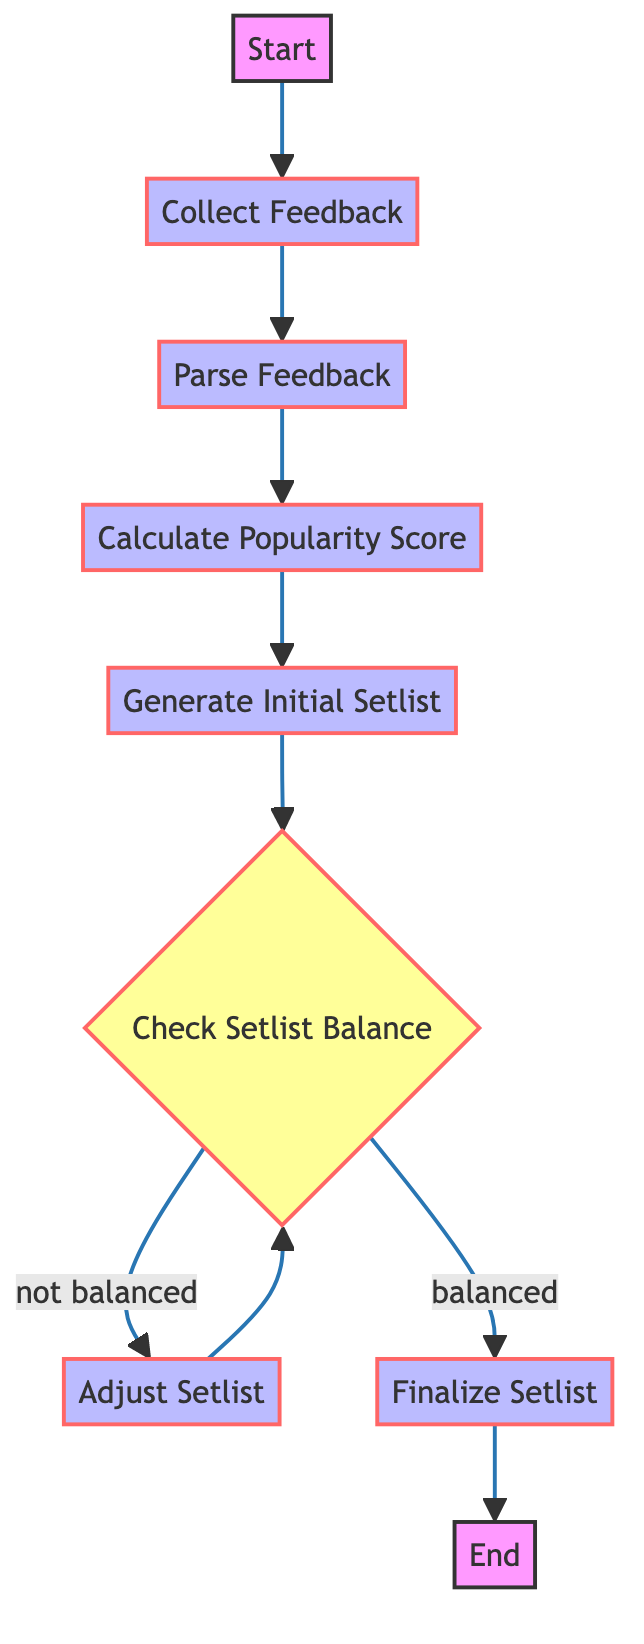What is the first step in the setlist generation process? The first step, as indicated in the diagram, is "Collect Feedback." This is the initial action that sets off the entire process of creating a setlist based on audience input.
Answer: Collect Feedback How many process nodes are present in the flowchart? By counting the nodes marked as "process" in the diagram, we identify a total of five process nodes. They include "Collect Feedback," "Parse Feedback," "Calculate Popularity Score," "Generate Initial Setlist," and "Adjust Setlist."
Answer: Five What action is taken if the setlist is balanced? The action taken when the setlist is balanced, as shown in the flowchart, is to "Finalize Setlist." This indicates that the setlist meets the criteria and is ready for rehearsal.
Answer: Finalize Setlist What happens if the setlist is not balanced? If the setlist is not balanced, the flowchart directs us to "Adjust Setlist." This step involves revisiting and modifying the song list to achieve a better mix of energies.
Answer: Adjust Setlist What is the last step before ending the process? The last step before reaching the end of the flowchart is "Finalize Setlist." This indicates that the setlist has been completed and is ready for the next phase.
Answer: Finalize Setlist How does one get back to checking setlist balance after adjustment? After adjusting the setlist, the flowchart indicates to return to "Check Setlist Balance." This creates a loop to ensure the adjustments meet the balance requirements.
Answer: Check Setlist Balance Which node represents a decision point in the flowchart? The node that acts as a decision point is labeled "Check Setlist Balance." Here, the flow splits based on whether the setlist is balanced or not.
Answer: Check Setlist Balance What types of feedback do you collect? The feedback collected can originate from various sources, such as social media, surveys, and previous concert reviews, as described in the respective node of the diagram.
Answer: Audience feedback 